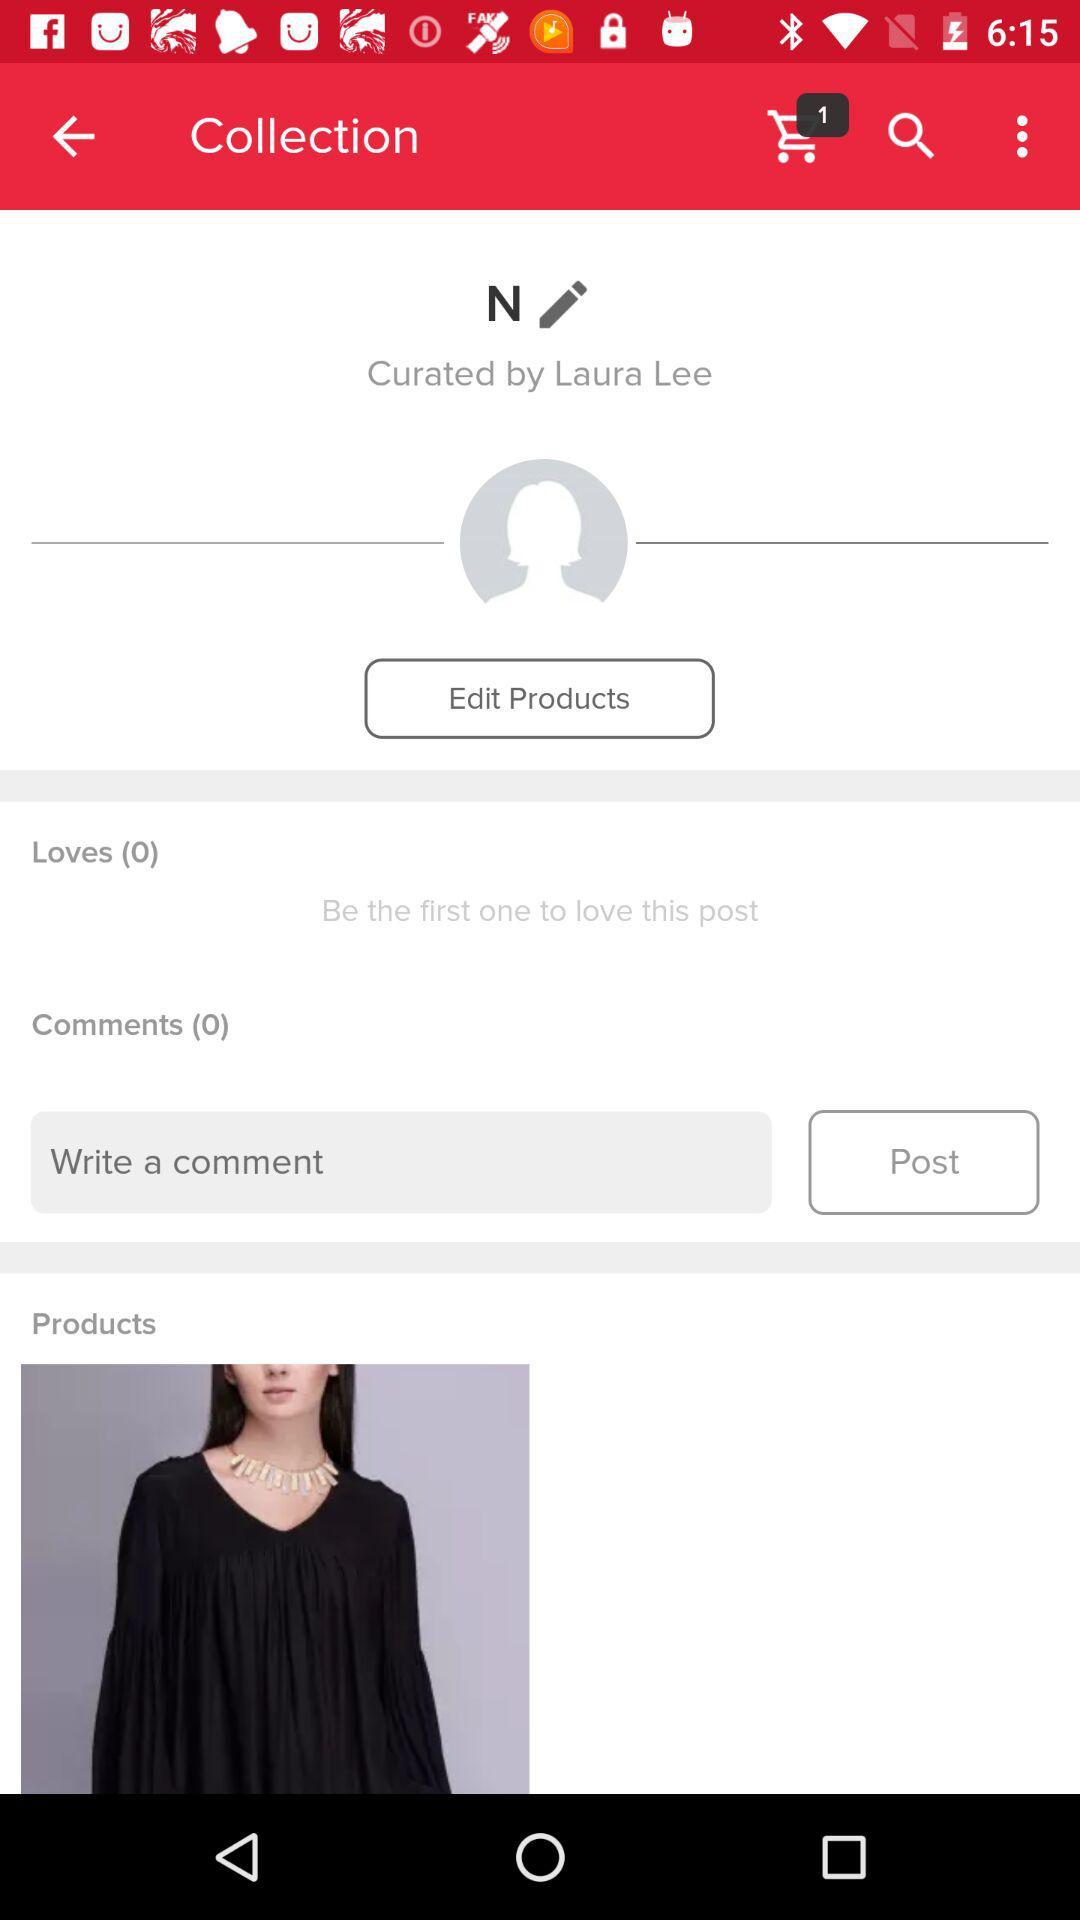How many people loved this post? This post was loved by 0 people. 